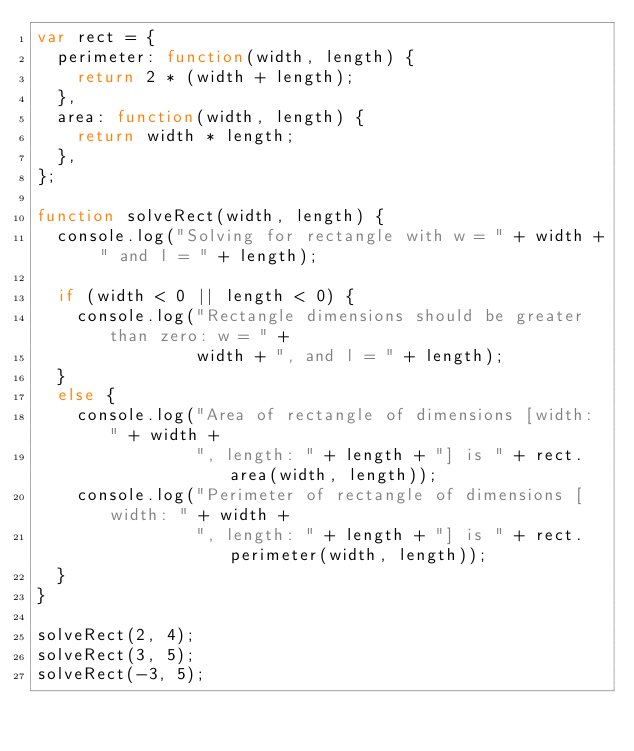<code> <loc_0><loc_0><loc_500><loc_500><_JavaScript_>var rect = {
  perimeter: function(width, length) {
    return 2 * (width + length);
  },
  area: function(width, length) {
    return width * length;
  },
};

function solveRect(width, length) {
  console.log("Solving for rectangle with w = " + width + " and l = " + length);

  if (width < 0 || length < 0) {
    console.log("Rectangle dimensions should be greater than zero: w = " +
                width + ", and l = " + length);
  }
  else {
    console.log("Area of rectangle of dimensions [width: " + width +
                ", length: " + length + "] is " + rect.area(width, length));
    console.log("Perimeter of rectangle of dimensions [width: " + width +
                ", length: " + length + "] is " + rect.perimeter(width, length));
  }
}

solveRect(2, 4);
solveRect(3, 5);
solveRect(-3, 5);
</code> 